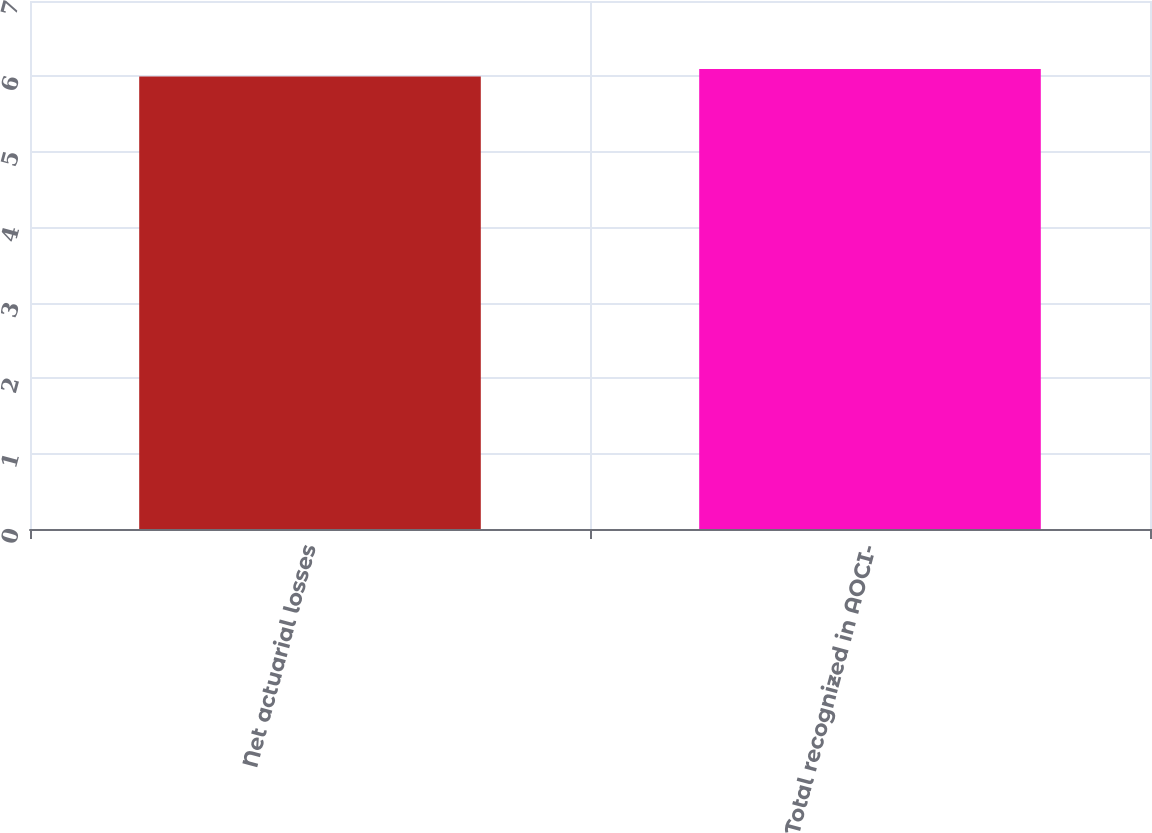Convert chart to OTSL. <chart><loc_0><loc_0><loc_500><loc_500><bar_chart><fcel>Net actuarial losses<fcel>Total recognized in AOCI-<nl><fcel>6<fcel>6.1<nl></chart> 